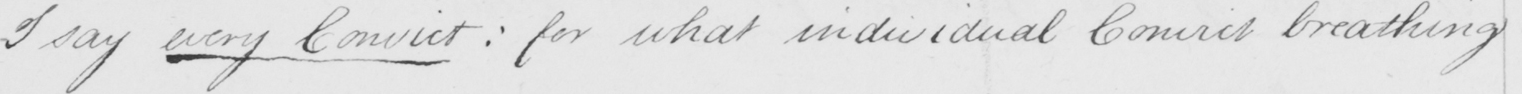Please transcribe the handwritten text in this image. I say every Convict :  for what individual Convict breathing 